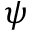<formula> <loc_0><loc_0><loc_500><loc_500>\psi</formula> 